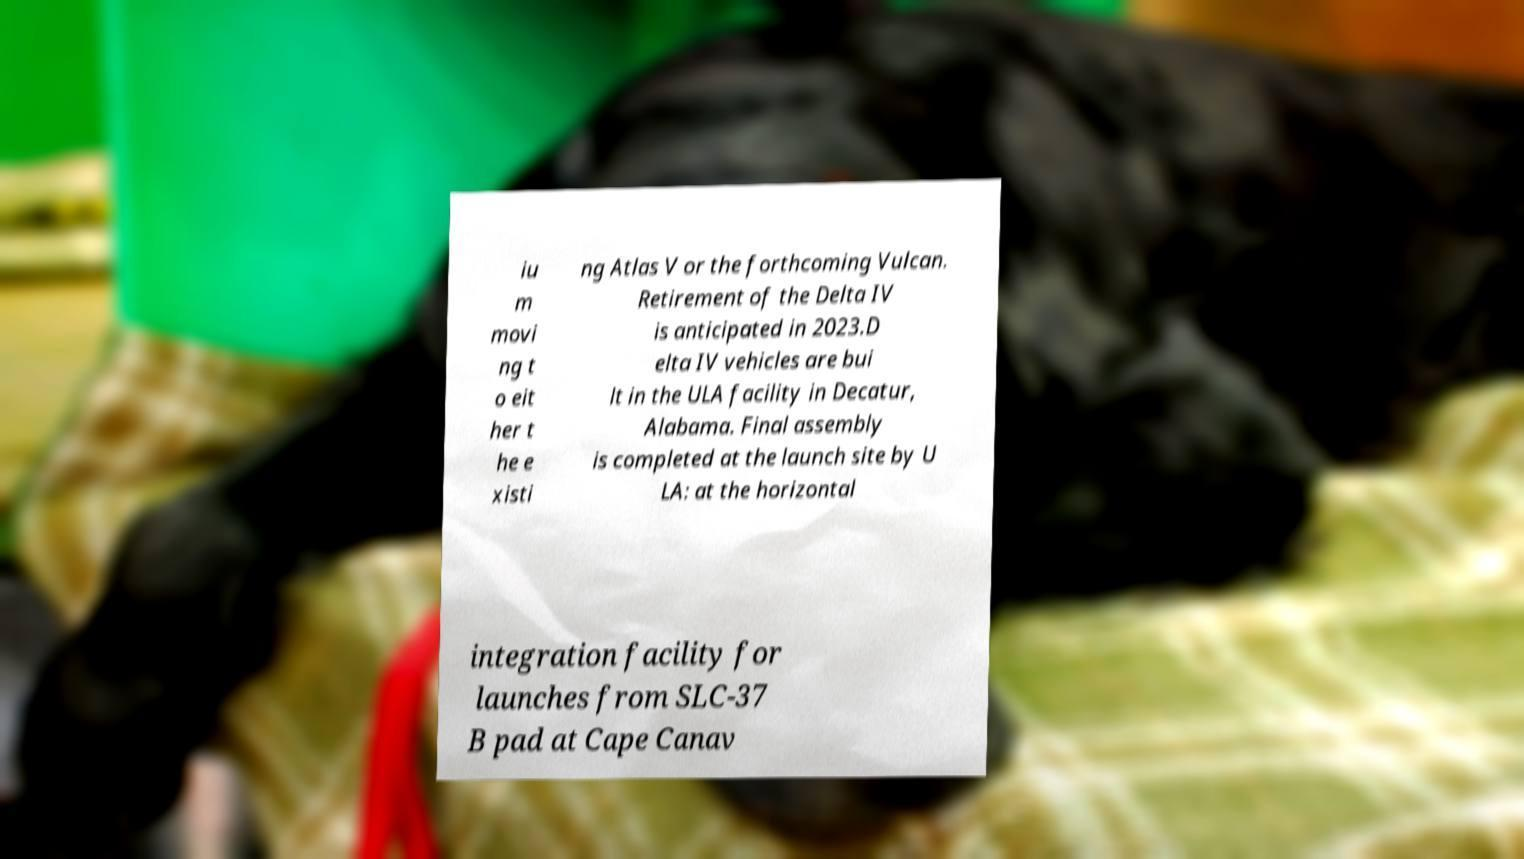Please read and relay the text visible in this image. What does it say? iu m movi ng t o eit her t he e xisti ng Atlas V or the forthcoming Vulcan. Retirement of the Delta IV is anticipated in 2023.D elta IV vehicles are bui lt in the ULA facility in Decatur, Alabama. Final assembly is completed at the launch site by U LA: at the horizontal integration facility for launches from SLC-37 B pad at Cape Canav 